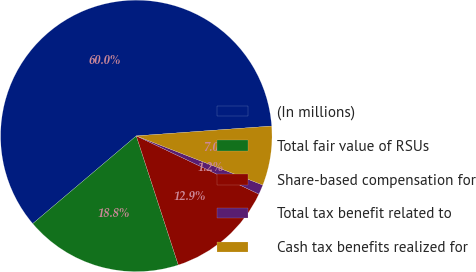Convert chart to OTSL. <chart><loc_0><loc_0><loc_500><loc_500><pie_chart><fcel>(In millions)<fcel>Total fair value of RSUs<fcel>Share-based compensation for<fcel>Total tax benefit related to<fcel>Cash tax benefits realized for<nl><fcel>60.03%<fcel>18.82%<fcel>12.94%<fcel>1.16%<fcel>7.05%<nl></chart> 